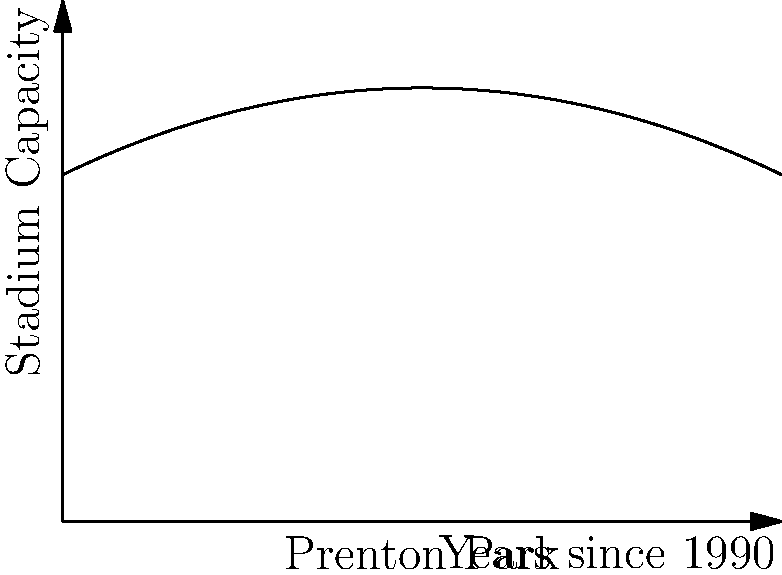The graph shows the capacity of Prenton Park, home of Tranmere Rovers, from 1990 to 2010. If the capacity $C$ (in thousands) is given by the function $C(t) = 10 + 0.5t - 0.025t^2$, where $t$ is the number of years since 1990, at what year was the rate of change of the stadium's capacity equal to zero? To find when the rate of change of the stadium's capacity was zero, we need to follow these steps:

1) The rate of change is given by the derivative of the capacity function:
   $C'(t) = \frac{d}{dt}(10 + 0.5t - 0.025t^2)$
   
2) Using the power rule, we get:
   $C'(t) = 0.5 - 0.05t$
   
3) We want to find when this rate of change equals zero:
   $0.5 - 0.05t = 0$
   
4) Solving for $t$:
   $0.05t = 0.5$
   $t = 10$
   
5) Since $t$ represents the number of years since 1990, we add 10 to 1990:
   1990 + 10 = 2000

Therefore, the rate of change of the stadium's capacity was equal to zero in the year 2000.
Answer: 2000 